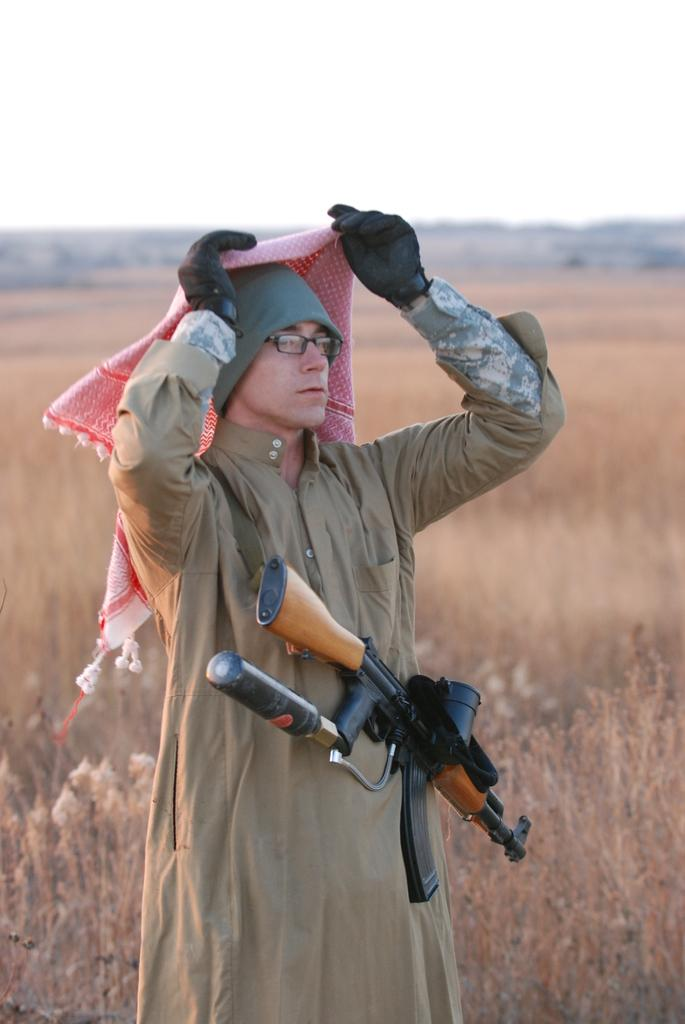What is the main subject of the image? There is a man in the image. What is the man wearing? The man is wearing a gun with a belt. Where is the man standing? The man is standing on the ground. What is the man holding? The man is holding a scarf. What type of natural elements can be seen in the image? There are plants visible in the image. What is visible in the background of the image? The sky is visible in the image. How many toes can be seen on the man's feet in the image? There is no visible indication of the man's feet or toes in the image. What letter is written on the man's shirt in the image? There is no shirt visible in the image, and therefore no letter can be identified. 